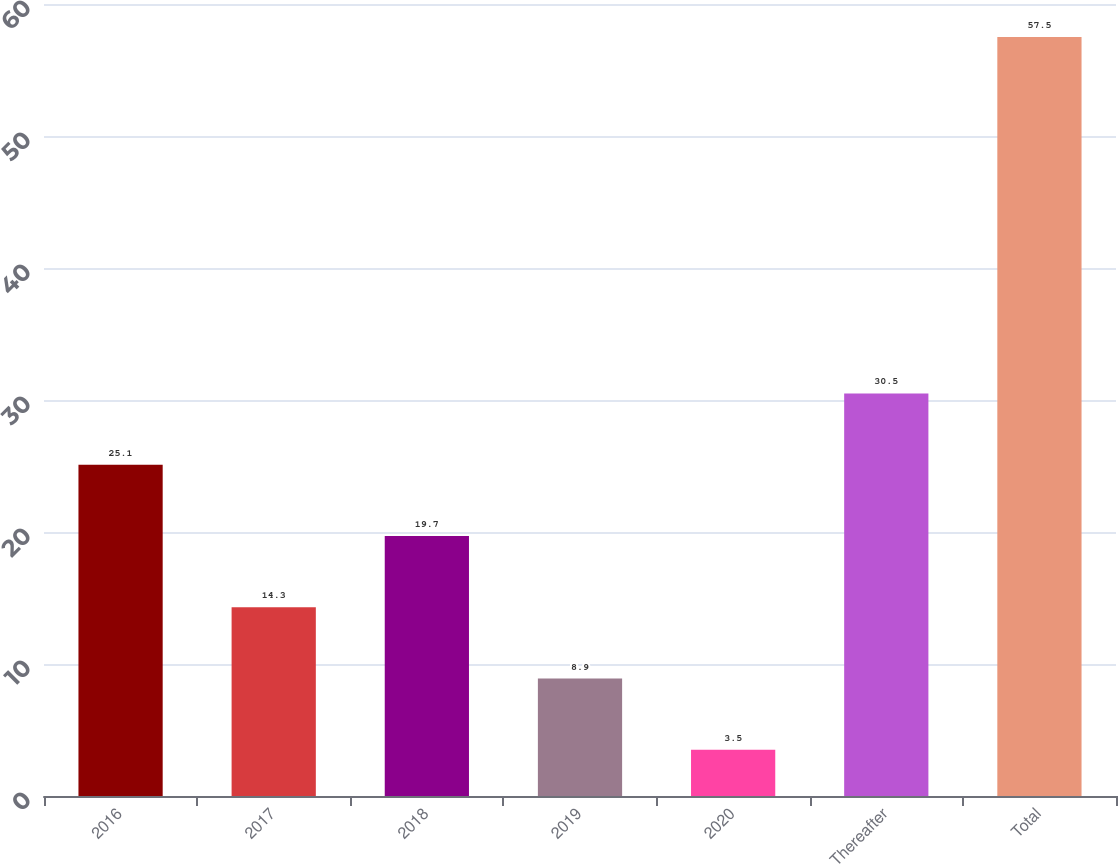Convert chart. <chart><loc_0><loc_0><loc_500><loc_500><bar_chart><fcel>2016<fcel>2017<fcel>2018<fcel>2019<fcel>2020<fcel>Thereafter<fcel>Total<nl><fcel>25.1<fcel>14.3<fcel>19.7<fcel>8.9<fcel>3.5<fcel>30.5<fcel>57.5<nl></chart> 